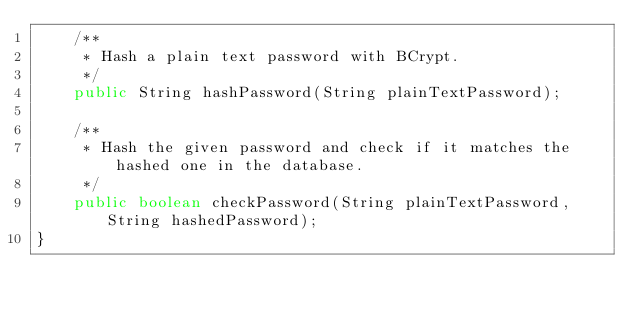<code> <loc_0><loc_0><loc_500><loc_500><_Java_>    /**
     * Hash a plain text password with BCrypt.
     */
    public String hashPassword(String plainTextPassword);

    /**
     * Hash the given password and check if it matches the hashed one in the database.
     */
    public boolean checkPassword(String plainTextPassword, String hashedPassword);
}</code> 